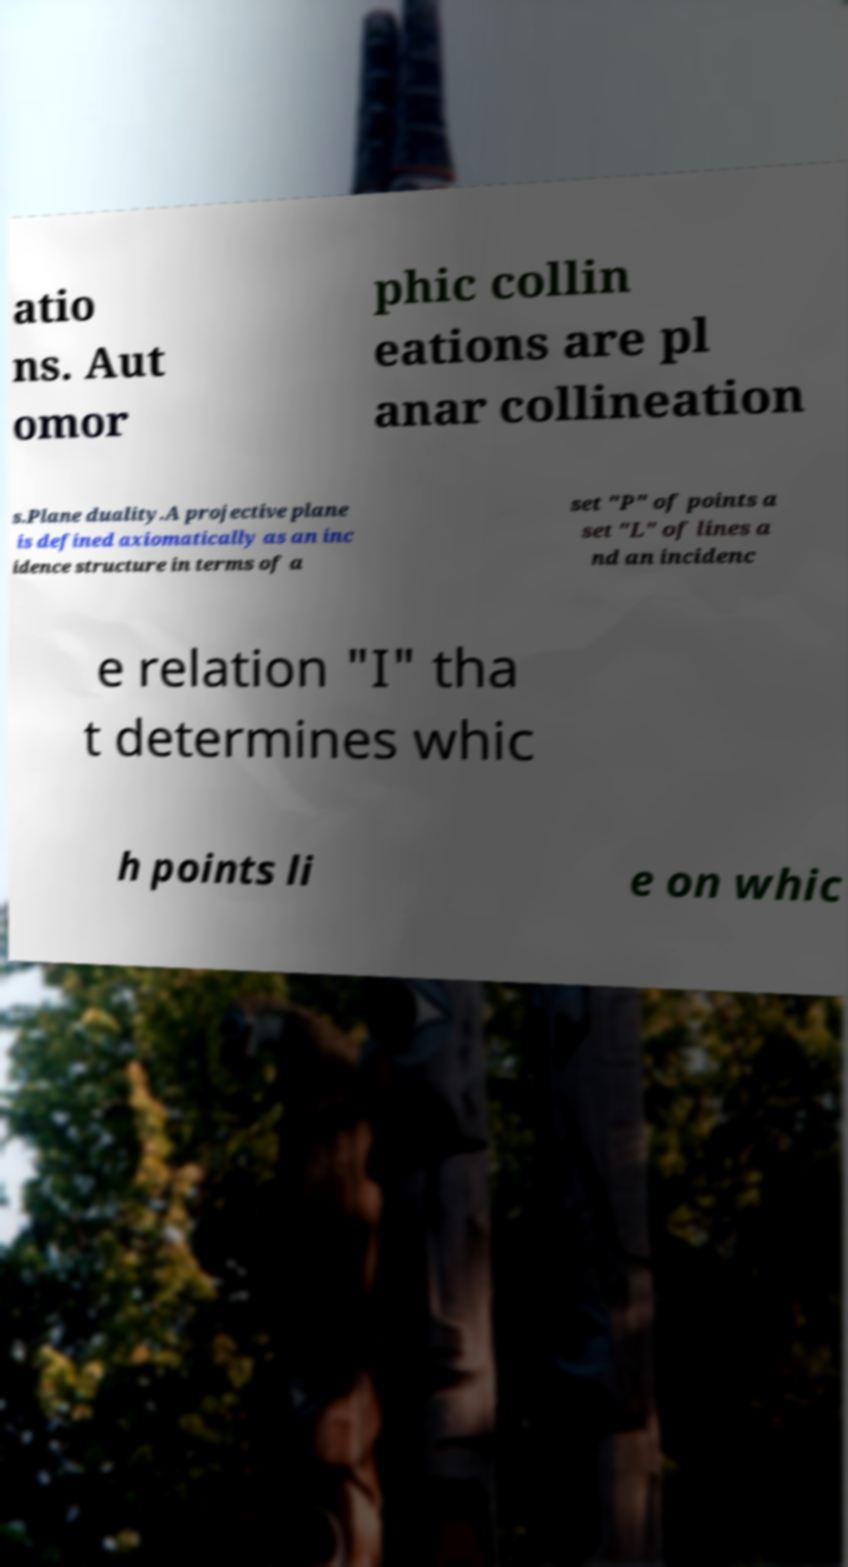Can you read and provide the text displayed in the image?This photo seems to have some interesting text. Can you extract and type it out for me? atio ns. Aut omor phic collin eations are pl anar collineation s.Plane duality.A projective plane is defined axiomatically as an inc idence structure in terms of a set "P" of points a set "L" of lines a nd an incidenc e relation "I" tha t determines whic h points li e on whic 